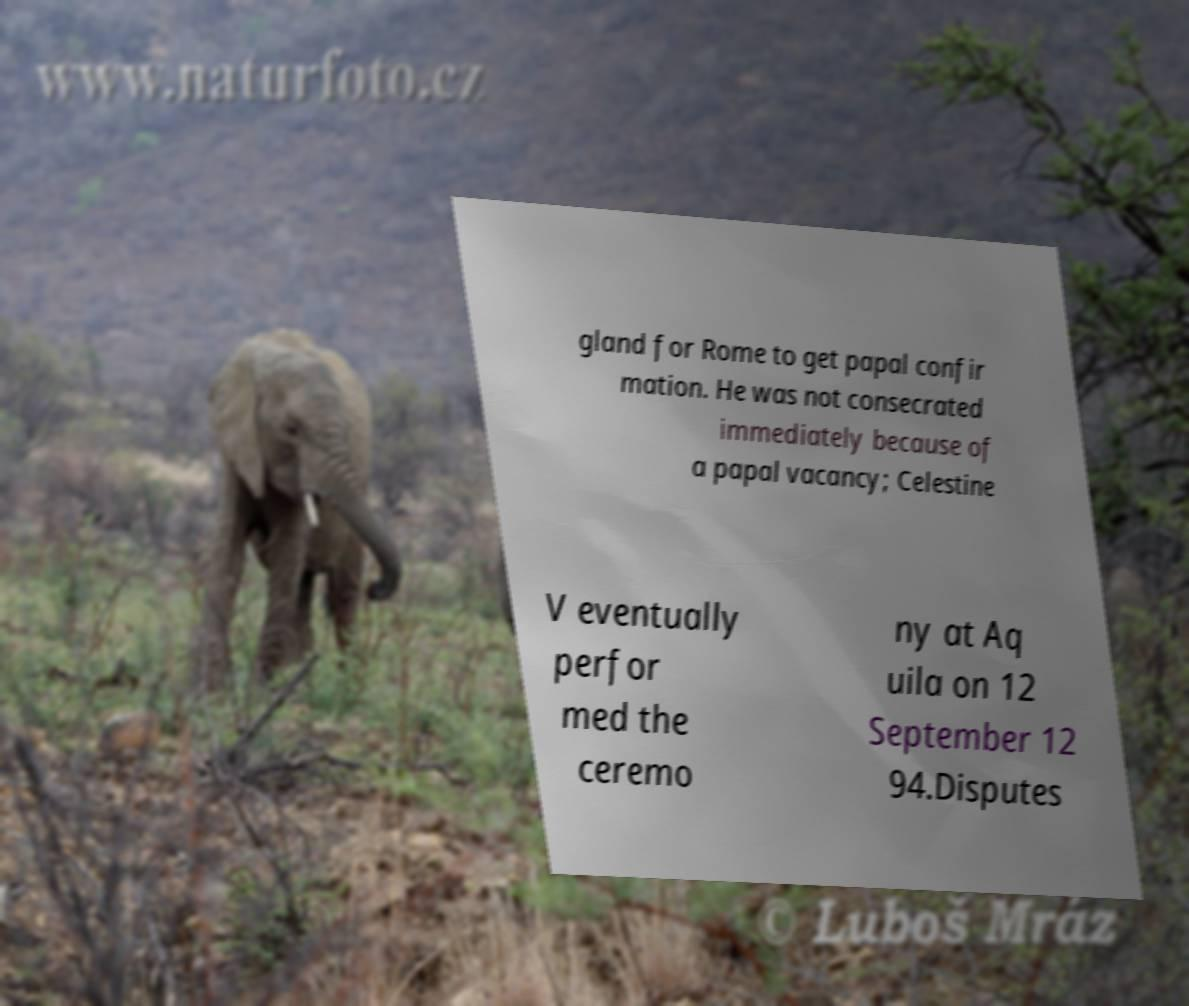Can you read and provide the text displayed in the image?This photo seems to have some interesting text. Can you extract and type it out for me? gland for Rome to get papal confir mation. He was not consecrated immediately because of a papal vacancy; Celestine V eventually perfor med the ceremo ny at Aq uila on 12 September 12 94.Disputes 